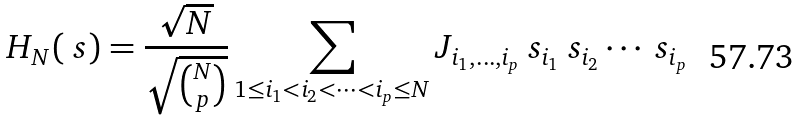Convert formula to latex. <formula><loc_0><loc_0><loc_500><loc_500>H _ { N } ( \ s ) = \frac { \sqrt { N } } { \sqrt { N \choose p } } \sum _ { 1 \leq i _ { 1 } < i _ { 2 } < \dots < i _ { p } \leq N } J _ { i _ { 1 } , \dots , i _ { p } } \ s _ { i _ { 1 } } \ s _ { i _ { 2 } } \cdots \ s _ { i _ { p } }</formula> 